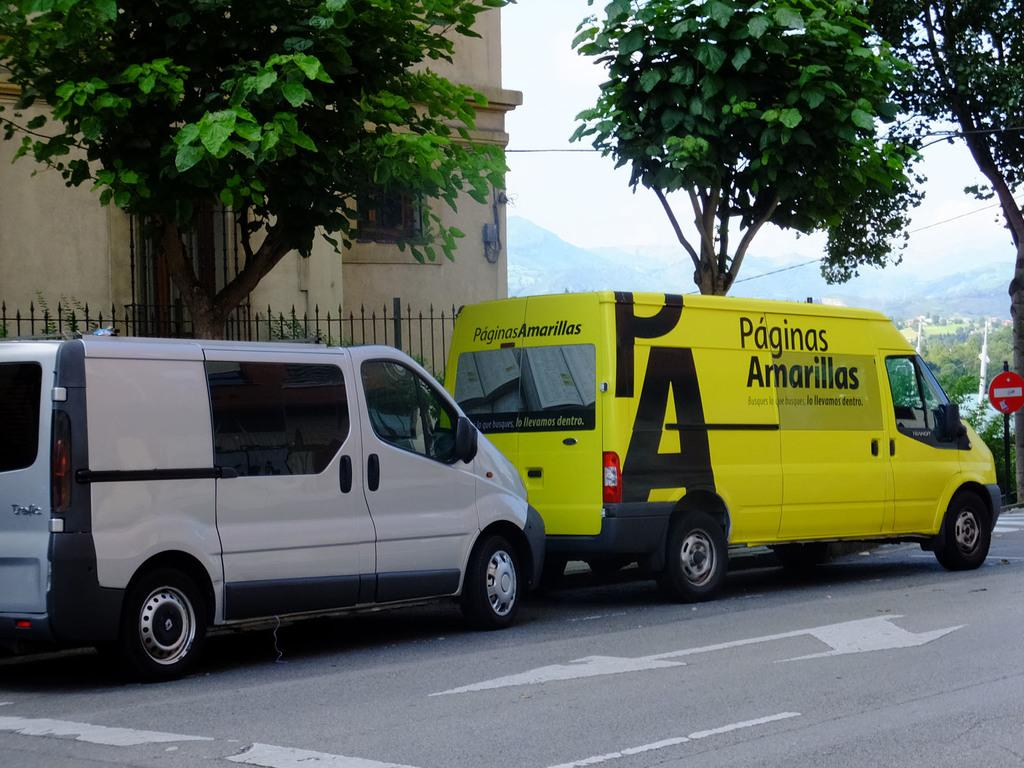What can be seen moving on the road in the image? There are vehicles on the road in the image. What is present to provide information or directions in the image? There is a sign board in the image. What structure separates or encloses areas in the image? There is a fence in the image. What type of man-made structure is visible in the image? There is a building in the image. What type of natural vegetation is present in the image? There are trees in the image. What type of vertical structures are present in the image? There are poles in the image. What type of large landforms can be seen in the distance in the image? There are mountains in the image. What part of the natural environment is visible in the background of the image? The sky is visible in the background of the image. How does the temper of the hand affect the blow in the image? There is no mention of temper, hand, or blow in the image. These elements are not present, and therefore their relationship cannot be determined. 